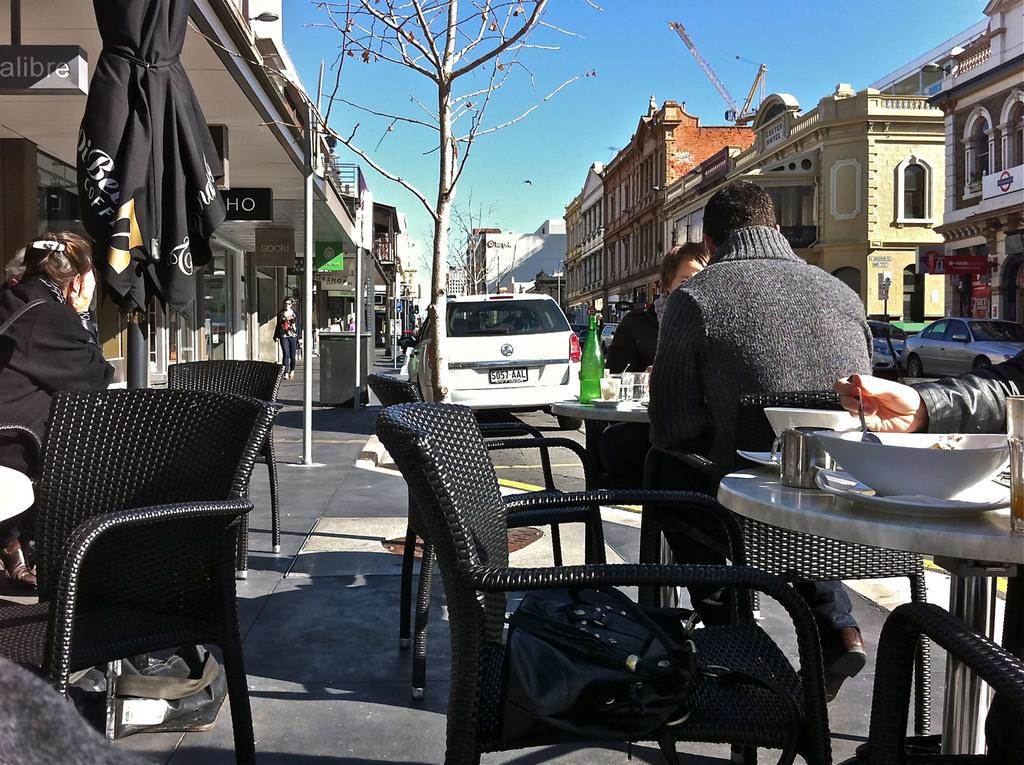What is the setting of the image? There are people sitting in a restaurant. Where is the restaurant located in relation to the road? The restaurant is beside a road. What can be seen in the background of the image? There is a road visible in the image. Are there any vehicles visible in the image? Yes, there is a white car at a distance in the image. What time of day is the morning meeting taking place in the image? There is no mention of a morning meeting in the image; it simply shows people sitting in a restaurant. 